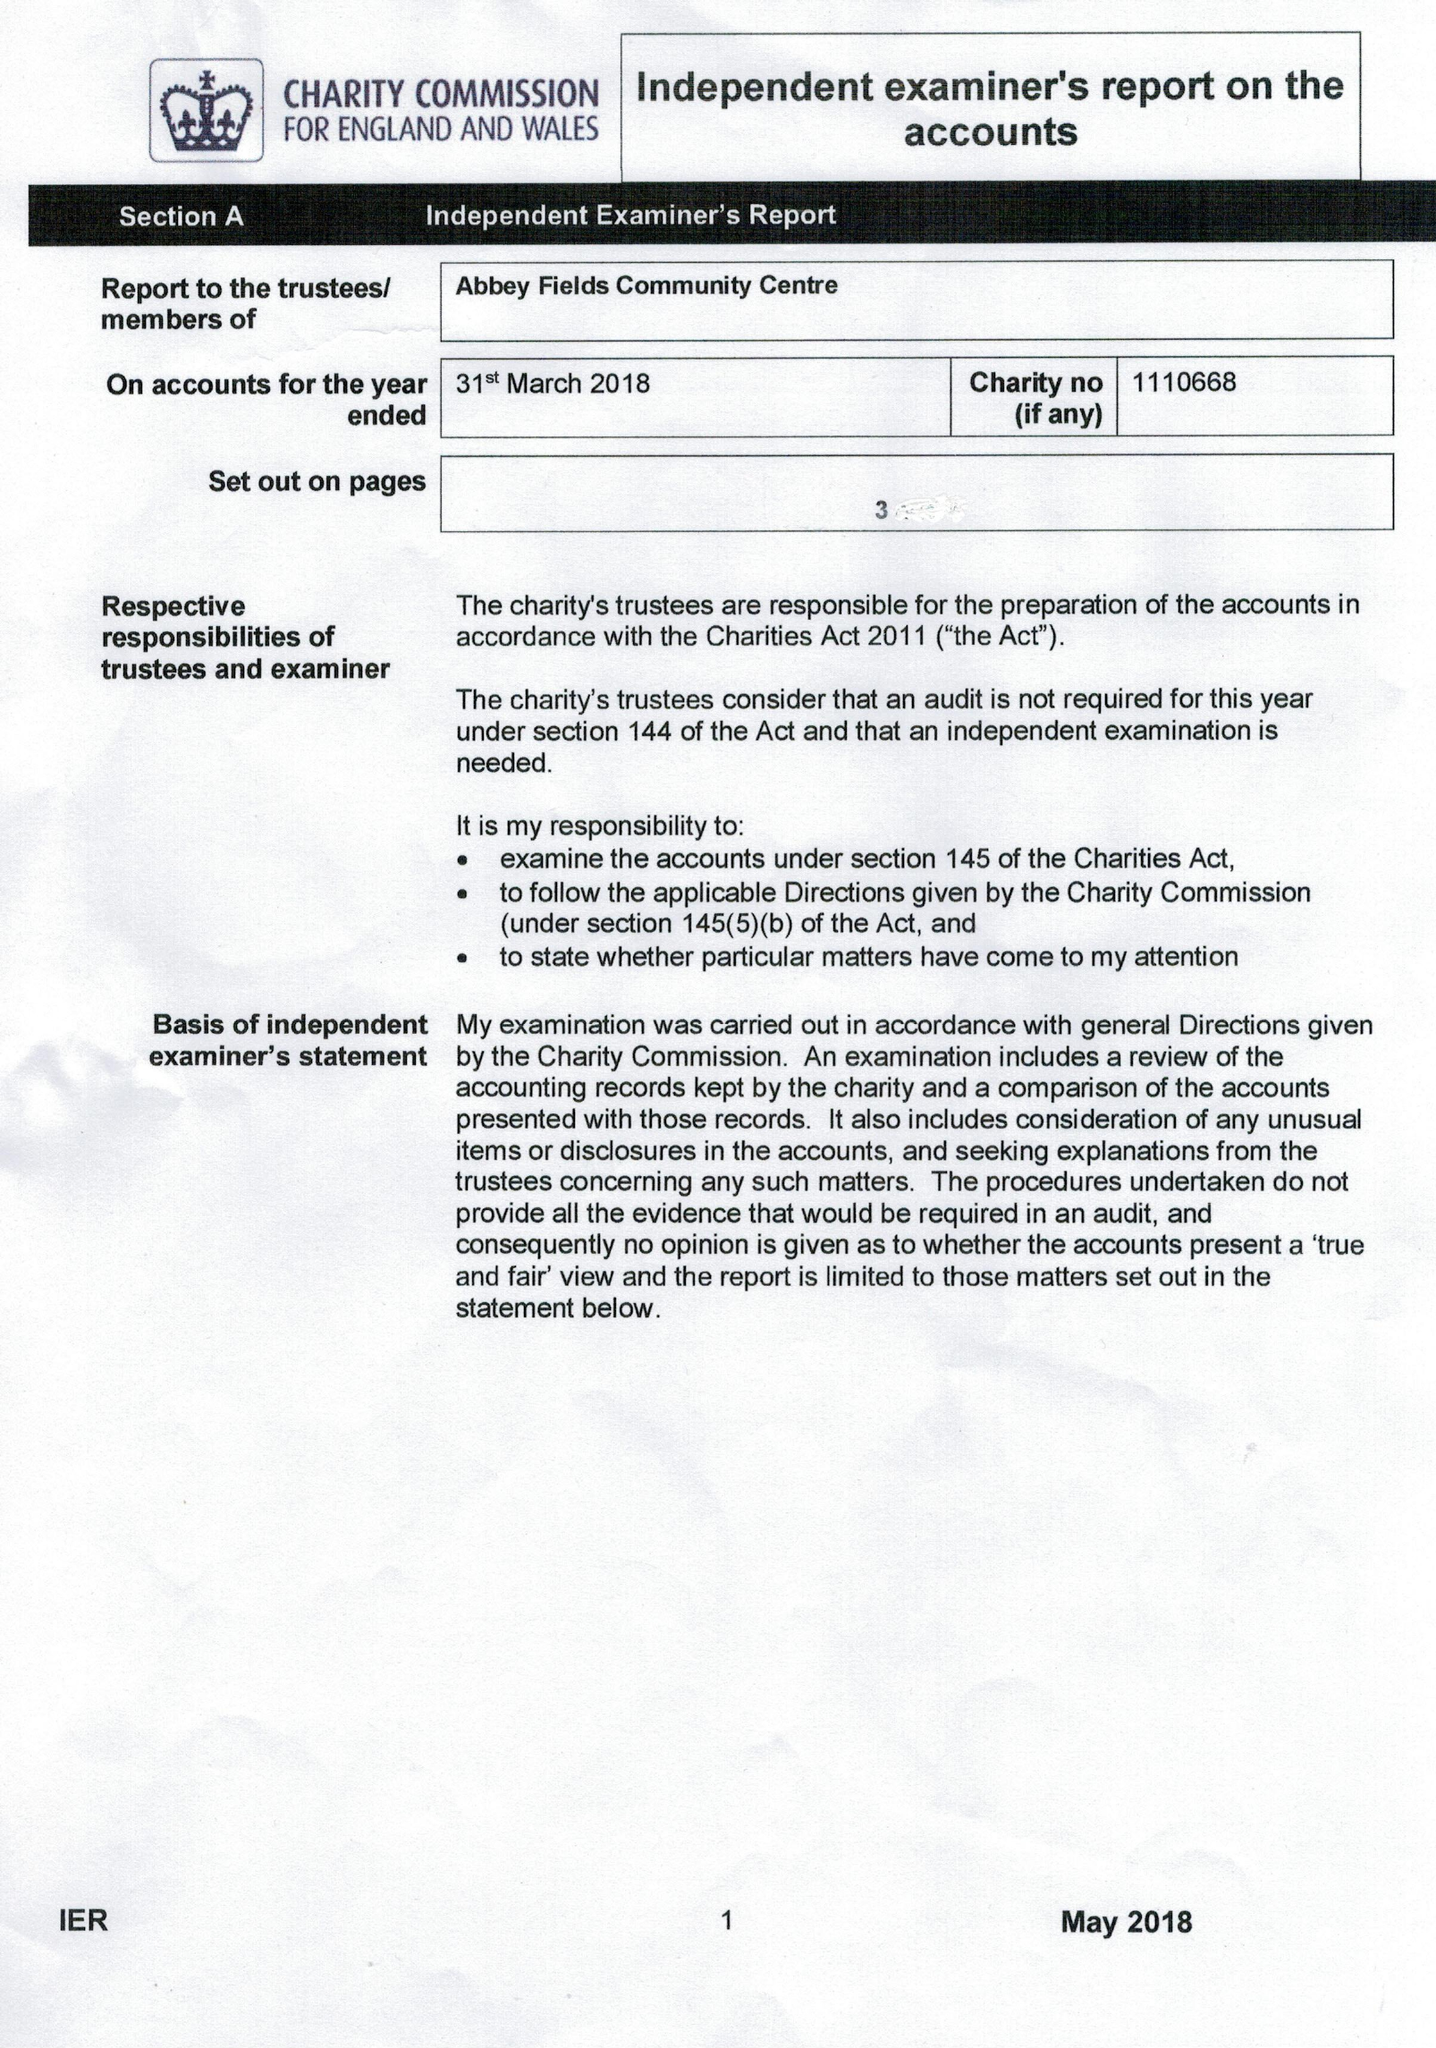What is the value for the address__postcode?
Answer the question using a single word or phrase. GL54 5QH 